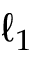Convert formula to latex. <formula><loc_0><loc_0><loc_500><loc_500>\ell _ { 1 }</formula> 